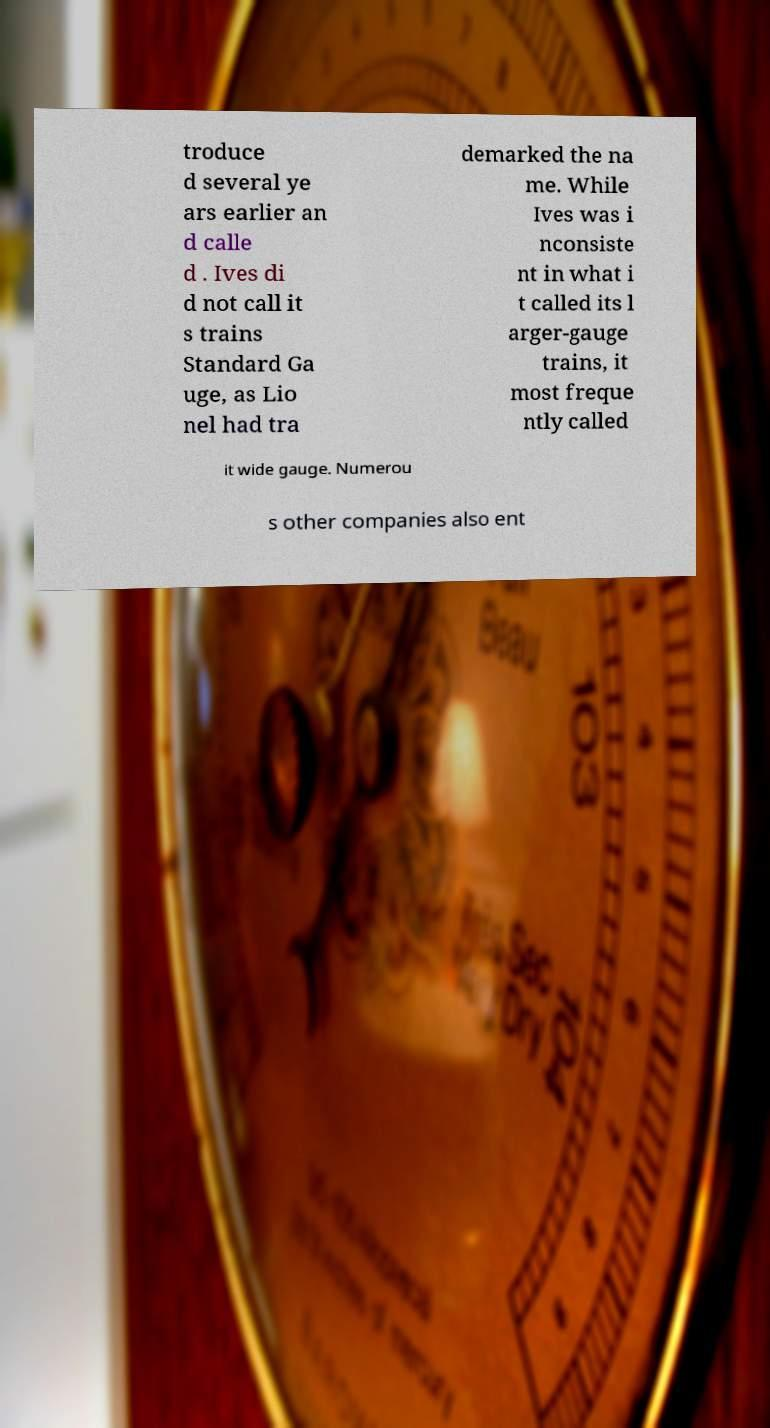I need the written content from this picture converted into text. Can you do that? troduce d several ye ars earlier an d calle d . Ives di d not call it s trains Standard Ga uge, as Lio nel had tra demarked the na me. While Ives was i nconsiste nt in what i t called its l arger-gauge trains, it most freque ntly called it wide gauge. Numerou s other companies also ent 